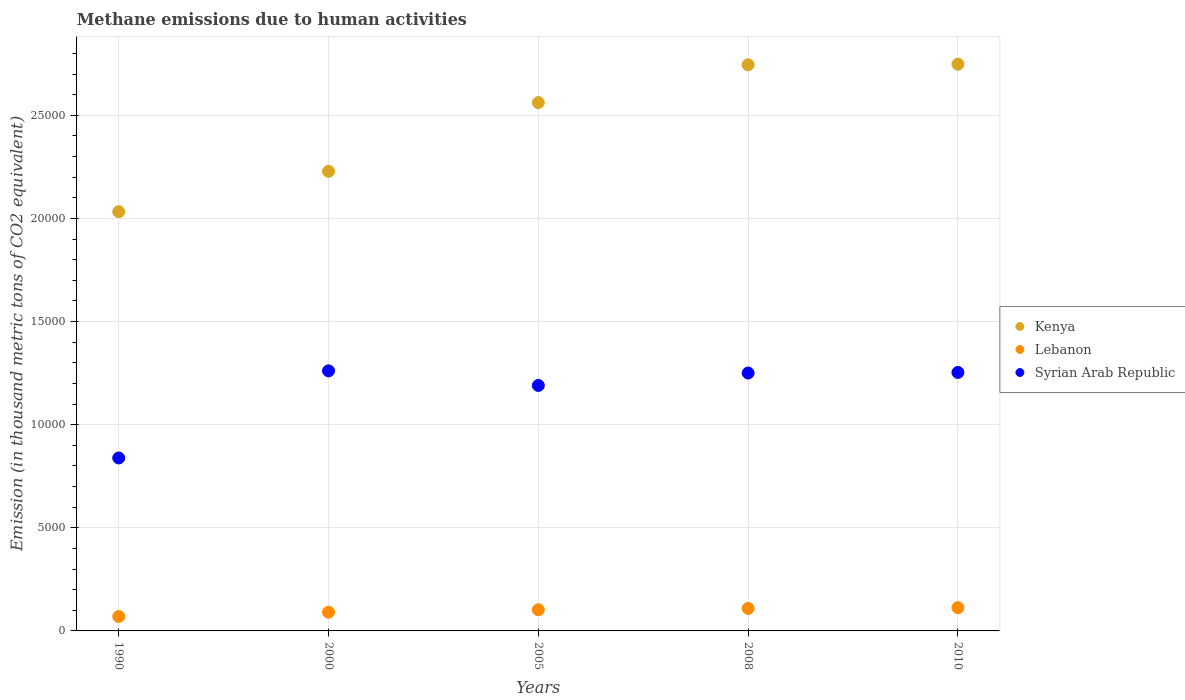How many different coloured dotlines are there?
Give a very brief answer. 3. What is the amount of methane emitted in Syrian Arab Republic in 2000?
Give a very brief answer. 1.26e+04. Across all years, what is the maximum amount of methane emitted in Syrian Arab Republic?
Provide a succinct answer. 1.26e+04. Across all years, what is the minimum amount of methane emitted in Lebanon?
Make the answer very short. 699. In which year was the amount of methane emitted in Lebanon maximum?
Make the answer very short. 2010. What is the total amount of methane emitted in Kenya in the graph?
Provide a short and direct response. 1.23e+05. What is the difference between the amount of methane emitted in Kenya in 1990 and that in 2000?
Offer a terse response. -1959.7. What is the difference between the amount of methane emitted in Lebanon in 1990 and the amount of methane emitted in Syrian Arab Republic in 2010?
Provide a succinct answer. -1.18e+04. What is the average amount of methane emitted in Kenya per year?
Offer a terse response. 2.46e+04. In the year 2010, what is the difference between the amount of methane emitted in Lebanon and amount of methane emitted in Syrian Arab Republic?
Keep it short and to the point. -1.14e+04. In how many years, is the amount of methane emitted in Syrian Arab Republic greater than 9000 thousand metric tons?
Offer a very short reply. 4. What is the ratio of the amount of methane emitted in Kenya in 1990 to that in 2005?
Give a very brief answer. 0.79. Is the difference between the amount of methane emitted in Lebanon in 1990 and 2005 greater than the difference between the amount of methane emitted in Syrian Arab Republic in 1990 and 2005?
Keep it short and to the point. Yes. What is the difference between the highest and the second highest amount of methane emitted in Kenya?
Your answer should be very brief. 29.4. What is the difference between the highest and the lowest amount of methane emitted in Lebanon?
Provide a short and direct response. 428.4. Is the sum of the amount of methane emitted in Syrian Arab Republic in 1990 and 2005 greater than the maximum amount of methane emitted in Lebanon across all years?
Offer a very short reply. Yes. Is it the case that in every year, the sum of the amount of methane emitted in Syrian Arab Republic and amount of methane emitted in Kenya  is greater than the amount of methane emitted in Lebanon?
Give a very brief answer. Yes. Does the amount of methane emitted in Syrian Arab Republic monotonically increase over the years?
Provide a succinct answer. No. Is the amount of methane emitted in Syrian Arab Republic strictly less than the amount of methane emitted in Lebanon over the years?
Offer a terse response. No. Are the values on the major ticks of Y-axis written in scientific E-notation?
Your response must be concise. No. Does the graph contain grids?
Offer a terse response. Yes. Where does the legend appear in the graph?
Provide a succinct answer. Center right. What is the title of the graph?
Make the answer very short. Methane emissions due to human activities. What is the label or title of the X-axis?
Ensure brevity in your answer.  Years. What is the label or title of the Y-axis?
Make the answer very short. Emission (in thousand metric tons of CO2 equivalent). What is the Emission (in thousand metric tons of CO2 equivalent) of Kenya in 1990?
Your answer should be very brief. 2.03e+04. What is the Emission (in thousand metric tons of CO2 equivalent) of Lebanon in 1990?
Offer a very short reply. 699. What is the Emission (in thousand metric tons of CO2 equivalent) of Syrian Arab Republic in 1990?
Your response must be concise. 8384.9. What is the Emission (in thousand metric tons of CO2 equivalent) in Kenya in 2000?
Keep it short and to the point. 2.23e+04. What is the Emission (in thousand metric tons of CO2 equivalent) in Lebanon in 2000?
Your response must be concise. 906.6. What is the Emission (in thousand metric tons of CO2 equivalent) of Syrian Arab Republic in 2000?
Your answer should be compact. 1.26e+04. What is the Emission (in thousand metric tons of CO2 equivalent) of Kenya in 2005?
Give a very brief answer. 2.56e+04. What is the Emission (in thousand metric tons of CO2 equivalent) in Lebanon in 2005?
Give a very brief answer. 1024.8. What is the Emission (in thousand metric tons of CO2 equivalent) in Syrian Arab Republic in 2005?
Your answer should be very brief. 1.19e+04. What is the Emission (in thousand metric tons of CO2 equivalent) in Kenya in 2008?
Ensure brevity in your answer.  2.74e+04. What is the Emission (in thousand metric tons of CO2 equivalent) in Lebanon in 2008?
Your response must be concise. 1091.7. What is the Emission (in thousand metric tons of CO2 equivalent) in Syrian Arab Republic in 2008?
Offer a terse response. 1.25e+04. What is the Emission (in thousand metric tons of CO2 equivalent) of Kenya in 2010?
Make the answer very short. 2.75e+04. What is the Emission (in thousand metric tons of CO2 equivalent) in Lebanon in 2010?
Your answer should be compact. 1127.4. What is the Emission (in thousand metric tons of CO2 equivalent) in Syrian Arab Republic in 2010?
Offer a very short reply. 1.25e+04. Across all years, what is the maximum Emission (in thousand metric tons of CO2 equivalent) in Kenya?
Your answer should be compact. 2.75e+04. Across all years, what is the maximum Emission (in thousand metric tons of CO2 equivalent) of Lebanon?
Offer a very short reply. 1127.4. Across all years, what is the maximum Emission (in thousand metric tons of CO2 equivalent) of Syrian Arab Republic?
Your answer should be very brief. 1.26e+04. Across all years, what is the minimum Emission (in thousand metric tons of CO2 equivalent) of Kenya?
Provide a short and direct response. 2.03e+04. Across all years, what is the minimum Emission (in thousand metric tons of CO2 equivalent) in Lebanon?
Make the answer very short. 699. Across all years, what is the minimum Emission (in thousand metric tons of CO2 equivalent) in Syrian Arab Republic?
Your response must be concise. 8384.9. What is the total Emission (in thousand metric tons of CO2 equivalent) of Kenya in the graph?
Offer a very short reply. 1.23e+05. What is the total Emission (in thousand metric tons of CO2 equivalent) of Lebanon in the graph?
Ensure brevity in your answer.  4849.5. What is the total Emission (in thousand metric tons of CO2 equivalent) in Syrian Arab Republic in the graph?
Your answer should be very brief. 5.79e+04. What is the difference between the Emission (in thousand metric tons of CO2 equivalent) in Kenya in 1990 and that in 2000?
Offer a very short reply. -1959.7. What is the difference between the Emission (in thousand metric tons of CO2 equivalent) in Lebanon in 1990 and that in 2000?
Give a very brief answer. -207.6. What is the difference between the Emission (in thousand metric tons of CO2 equivalent) in Syrian Arab Republic in 1990 and that in 2000?
Ensure brevity in your answer.  -4223.9. What is the difference between the Emission (in thousand metric tons of CO2 equivalent) in Kenya in 1990 and that in 2005?
Give a very brief answer. -5291.2. What is the difference between the Emission (in thousand metric tons of CO2 equivalent) of Lebanon in 1990 and that in 2005?
Make the answer very short. -325.8. What is the difference between the Emission (in thousand metric tons of CO2 equivalent) of Syrian Arab Republic in 1990 and that in 2005?
Ensure brevity in your answer.  -3516.3. What is the difference between the Emission (in thousand metric tons of CO2 equivalent) in Kenya in 1990 and that in 2008?
Keep it short and to the point. -7123.6. What is the difference between the Emission (in thousand metric tons of CO2 equivalent) of Lebanon in 1990 and that in 2008?
Offer a very short reply. -392.7. What is the difference between the Emission (in thousand metric tons of CO2 equivalent) in Syrian Arab Republic in 1990 and that in 2008?
Provide a succinct answer. -4118.9. What is the difference between the Emission (in thousand metric tons of CO2 equivalent) of Kenya in 1990 and that in 2010?
Offer a terse response. -7153. What is the difference between the Emission (in thousand metric tons of CO2 equivalent) in Lebanon in 1990 and that in 2010?
Your answer should be very brief. -428.4. What is the difference between the Emission (in thousand metric tons of CO2 equivalent) in Syrian Arab Republic in 1990 and that in 2010?
Provide a short and direct response. -4147.2. What is the difference between the Emission (in thousand metric tons of CO2 equivalent) in Kenya in 2000 and that in 2005?
Provide a short and direct response. -3331.5. What is the difference between the Emission (in thousand metric tons of CO2 equivalent) in Lebanon in 2000 and that in 2005?
Provide a short and direct response. -118.2. What is the difference between the Emission (in thousand metric tons of CO2 equivalent) of Syrian Arab Republic in 2000 and that in 2005?
Make the answer very short. 707.6. What is the difference between the Emission (in thousand metric tons of CO2 equivalent) of Kenya in 2000 and that in 2008?
Keep it short and to the point. -5163.9. What is the difference between the Emission (in thousand metric tons of CO2 equivalent) in Lebanon in 2000 and that in 2008?
Offer a very short reply. -185.1. What is the difference between the Emission (in thousand metric tons of CO2 equivalent) of Syrian Arab Republic in 2000 and that in 2008?
Give a very brief answer. 105. What is the difference between the Emission (in thousand metric tons of CO2 equivalent) in Kenya in 2000 and that in 2010?
Your response must be concise. -5193.3. What is the difference between the Emission (in thousand metric tons of CO2 equivalent) in Lebanon in 2000 and that in 2010?
Ensure brevity in your answer.  -220.8. What is the difference between the Emission (in thousand metric tons of CO2 equivalent) in Syrian Arab Republic in 2000 and that in 2010?
Your answer should be compact. 76.7. What is the difference between the Emission (in thousand metric tons of CO2 equivalent) in Kenya in 2005 and that in 2008?
Keep it short and to the point. -1832.4. What is the difference between the Emission (in thousand metric tons of CO2 equivalent) of Lebanon in 2005 and that in 2008?
Provide a succinct answer. -66.9. What is the difference between the Emission (in thousand metric tons of CO2 equivalent) of Syrian Arab Republic in 2005 and that in 2008?
Your response must be concise. -602.6. What is the difference between the Emission (in thousand metric tons of CO2 equivalent) in Kenya in 2005 and that in 2010?
Give a very brief answer. -1861.8. What is the difference between the Emission (in thousand metric tons of CO2 equivalent) of Lebanon in 2005 and that in 2010?
Make the answer very short. -102.6. What is the difference between the Emission (in thousand metric tons of CO2 equivalent) of Syrian Arab Republic in 2005 and that in 2010?
Your response must be concise. -630.9. What is the difference between the Emission (in thousand metric tons of CO2 equivalent) in Kenya in 2008 and that in 2010?
Offer a very short reply. -29.4. What is the difference between the Emission (in thousand metric tons of CO2 equivalent) in Lebanon in 2008 and that in 2010?
Ensure brevity in your answer.  -35.7. What is the difference between the Emission (in thousand metric tons of CO2 equivalent) of Syrian Arab Republic in 2008 and that in 2010?
Make the answer very short. -28.3. What is the difference between the Emission (in thousand metric tons of CO2 equivalent) in Kenya in 1990 and the Emission (in thousand metric tons of CO2 equivalent) in Lebanon in 2000?
Provide a succinct answer. 1.94e+04. What is the difference between the Emission (in thousand metric tons of CO2 equivalent) of Kenya in 1990 and the Emission (in thousand metric tons of CO2 equivalent) of Syrian Arab Republic in 2000?
Your response must be concise. 7715.5. What is the difference between the Emission (in thousand metric tons of CO2 equivalent) of Lebanon in 1990 and the Emission (in thousand metric tons of CO2 equivalent) of Syrian Arab Republic in 2000?
Your answer should be compact. -1.19e+04. What is the difference between the Emission (in thousand metric tons of CO2 equivalent) of Kenya in 1990 and the Emission (in thousand metric tons of CO2 equivalent) of Lebanon in 2005?
Provide a succinct answer. 1.93e+04. What is the difference between the Emission (in thousand metric tons of CO2 equivalent) of Kenya in 1990 and the Emission (in thousand metric tons of CO2 equivalent) of Syrian Arab Republic in 2005?
Give a very brief answer. 8423.1. What is the difference between the Emission (in thousand metric tons of CO2 equivalent) in Lebanon in 1990 and the Emission (in thousand metric tons of CO2 equivalent) in Syrian Arab Republic in 2005?
Your answer should be very brief. -1.12e+04. What is the difference between the Emission (in thousand metric tons of CO2 equivalent) in Kenya in 1990 and the Emission (in thousand metric tons of CO2 equivalent) in Lebanon in 2008?
Your answer should be compact. 1.92e+04. What is the difference between the Emission (in thousand metric tons of CO2 equivalent) of Kenya in 1990 and the Emission (in thousand metric tons of CO2 equivalent) of Syrian Arab Republic in 2008?
Make the answer very short. 7820.5. What is the difference between the Emission (in thousand metric tons of CO2 equivalent) in Lebanon in 1990 and the Emission (in thousand metric tons of CO2 equivalent) in Syrian Arab Republic in 2008?
Give a very brief answer. -1.18e+04. What is the difference between the Emission (in thousand metric tons of CO2 equivalent) of Kenya in 1990 and the Emission (in thousand metric tons of CO2 equivalent) of Lebanon in 2010?
Provide a succinct answer. 1.92e+04. What is the difference between the Emission (in thousand metric tons of CO2 equivalent) of Kenya in 1990 and the Emission (in thousand metric tons of CO2 equivalent) of Syrian Arab Republic in 2010?
Your response must be concise. 7792.2. What is the difference between the Emission (in thousand metric tons of CO2 equivalent) in Lebanon in 1990 and the Emission (in thousand metric tons of CO2 equivalent) in Syrian Arab Republic in 2010?
Keep it short and to the point. -1.18e+04. What is the difference between the Emission (in thousand metric tons of CO2 equivalent) of Kenya in 2000 and the Emission (in thousand metric tons of CO2 equivalent) of Lebanon in 2005?
Your response must be concise. 2.13e+04. What is the difference between the Emission (in thousand metric tons of CO2 equivalent) in Kenya in 2000 and the Emission (in thousand metric tons of CO2 equivalent) in Syrian Arab Republic in 2005?
Provide a short and direct response. 1.04e+04. What is the difference between the Emission (in thousand metric tons of CO2 equivalent) of Lebanon in 2000 and the Emission (in thousand metric tons of CO2 equivalent) of Syrian Arab Republic in 2005?
Ensure brevity in your answer.  -1.10e+04. What is the difference between the Emission (in thousand metric tons of CO2 equivalent) in Kenya in 2000 and the Emission (in thousand metric tons of CO2 equivalent) in Lebanon in 2008?
Give a very brief answer. 2.12e+04. What is the difference between the Emission (in thousand metric tons of CO2 equivalent) in Kenya in 2000 and the Emission (in thousand metric tons of CO2 equivalent) in Syrian Arab Republic in 2008?
Your response must be concise. 9780.2. What is the difference between the Emission (in thousand metric tons of CO2 equivalent) in Lebanon in 2000 and the Emission (in thousand metric tons of CO2 equivalent) in Syrian Arab Republic in 2008?
Your response must be concise. -1.16e+04. What is the difference between the Emission (in thousand metric tons of CO2 equivalent) of Kenya in 2000 and the Emission (in thousand metric tons of CO2 equivalent) of Lebanon in 2010?
Provide a succinct answer. 2.12e+04. What is the difference between the Emission (in thousand metric tons of CO2 equivalent) in Kenya in 2000 and the Emission (in thousand metric tons of CO2 equivalent) in Syrian Arab Republic in 2010?
Your answer should be compact. 9751.9. What is the difference between the Emission (in thousand metric tons of CO2 equivalent) in Lebanon in 2000 and the Emission (in thousand metric tons of CO2 equivalent) in Syrian Arab Republic in 2010?
Give a very brief answer. -1.16e+04. What is the difference between the Emission (in thousand metric tons of CO2 equivalent) in Kenya in 2005 and the Emission (in thousand metric tons of CO2 equivalent) in Lebanon in 2008?
Keep it short and to the point. 2.45e+04. What is the difference between the Emission (in thousand metric tons of CO2 equivalent) in Kenya in 2005 and the Emission (in thousand metric tons of CO2 equivalent) in Syrian Arab Republic in 2008?
Give a very brief answer. 1.31e+04. What is the difference between the Emission (in thousand metric tons of CO2 equivalent) in Lebanon in 2005 and the Emission (in thousand metric tons of CO2 equivalent) in Syrian Arab Republic in 2008?
Offer a very short reply. -1.15e+04. What is the difference between the Emission (in thousand metric tons of CO2 equivalent) in Kenya in 2005 and the Emission (in thousand metric tons of CO2 equivalent) in Lebanon in 2010?
Keep it short and to the point. 2.45e+04. What is the difference between the Emission (in thousand metric tons of CO2 equivalent) of Kenya in 2005 and the Emission (in thousand metric tons of CO2 equivalent) of Syrian Arab Republic in 2010?
Keep it short and to the point. 1.31e+04. What is the difference between the Emission (in thousand metric tons of CO2 equivalent) in Lebanon in 2005 and the Emission (in thousand metric tons of CO2 equivalent) in Syrian Arab Republic in 2010?
Give a very brief answer. -1.15e+04. What is the difference between the Emission (in thousand metric tons of CO2 equivalent) in Kenya in 2008 and the Emission (in thousand metric tons of CO2 equivalent) in Lebanon in 2010?
Make the answer very short. 2.63e+04. What is the difference between the Emission (in thousand metric tons of CO2 equivalent) in Kenya in 2008 and the Emission (in thousand metric tons of CO2 equivalent) in Syrian Arab Republic in 2010?
Your response must be concise. 1.49e+04. What is the difference between the Emission (in thousand metric tons of CO2 equivalent) of Lebanon in 2008 and the Emission (in thousand metric tons of CO2 equivalent) of Syrian Arab Republic in 2010?
Make the answer very short. -1.14e+04. What is the average Emission (in thousand metric tons of CO2 equivalent) of Kenya per year?
Offer a very short reply. 2.46e+04. What is the average Emission (in thousand metric tons of CO2 equivalent) in Lebanon per year?
Your answer should be very brief. 969.9. What is the average Emission (in thousand metric tons of CO2 equivalent) in Syrian Arab Republic per year?
Your answer should be very brief. 1.16e+04. In the year 1990, what is the difference between the Emission (in thousand metric tons of CO2 equivalent) of Kenya and Emission (in thousand metric tons of CO2 equivalent) of Lebanon?
Give a very brief answer. 1.96e+04. In the year 1990, what is the difference between the Emission (in thousand metric tons of CO2 equivalent) in Kenya and Emission (in thousand metric tons of CO2 equivalent) in Syrian Arab Republic?
Keep it short and to the point. 1.19e+04. In the year 1990, what is the difference between the Emission (in thousand metric tons of CO2 equivalent) in Lebanon and Emission (in thousand metric tons of CO2 equivalent) in Syrian Arab Republic?
Your answer should be very brief. -7685.9. In the year 2000, what is the difference between the Emission (in thousand metric tons of CO2 equivalent) of Kenya and Emission (in thousand metric tons of CO2 equivalent) of Lebanon?
Keep it short and to the point. 2.14e+04. In the year 2000, what is the difference between the Emission (in thousand metric tons of CO2 equivalent) of Kenya and Emission (in thousand metric tons of CO2 equivalent) of Syrian Arab Republic?
Give a very brief answer. 9675.2. In the year 2000, what is the difference between the Emission (in thousand metric tons of CO2 equivalent) in Lebanon and Emission (in thousand metric tons of CO2 equivalent) in Syrian Arab Republic?
Offer a very short reply. -1.17e+04. In the year 2005, what is the difference between the Emission (in thousand metric tons of CO2 equivalent) of Kenya and Emission (in thousand metric tons of CO2 equivalent) of Lebanon?
Your response must be concise. 2.46e+04. In the year 2005, what is the difference between the Emission (in thousand metric tons of CO2 equivalent) in Kenya and Emission (in thousand metric tons of CO2 equivalent) in Syrian Arab Republic?
Offer a terse response. 1.37e+04. In the year 2005, what is the difference between the Emission (in thousand metric tons of CO2 equivalent) of Lebanon and Emission (in thousand metric tons of CO2 equivalent) of Syrian Arab Republic?
Your answer should be very brief. -1.09e+04. In the year 2008, what is the difference between the Emission (in thousand metric tons of CO2 equivalent) in Kenya and Emission (in thousand metric tons of CO2 equivalent) in Lebanon?
Keep it short and to the point. 2.64e+04. In the year 2008, what is the difference between the Emission (in thousand metric tons of CO2 equivalent) of Kenya and Emission (in thousand metric tons of CO2 equivalent) of Syrian Arab Republic?
Provide a short and direct response. 1.49e+04. In the year 2008, what is the difference between the Emission (in thousand metric tons of CO2 equivalent) in Lebanon and Emission (in thousand metric tons of CO2 equivalent) in Syrian Arab Republic?
Ensure brevity in your answer.  -1.14e+04. In the year 2010, what is the difference between the Emission (in thousand metric tons of CO2 equivalent) of Kenya and Emission (in thousand metric tons of CO2 equivalent) of Lebanon?
Provide a succinct answer. 2.63e+04. In the year 2010, what is the difference between the Emission (in thousand metric tons of CO2 equivalent) of Kenya and Emission (in thousand metric tons of CO2 equivalent) of Syrian Arab Republic?
Provide a short and direct response. 1.49e+04. In the year 2010, what is the difference between the Emission (in thousand metric tons of CO2 equivalent) in Lebanon and Emission (in thousand metric tons of CO2 equivalent) in Syrian Arab Republic?
Provide a short and direct response. -1.14e+04. What is the ratio of the Emission (in thousand metric tons of CO2 equivalent) of Kenya in 1990 to that in 2000?
Make the answer very short. 0.91. What is the ratio of the Emission (in thousand metric tons of CO2 equivalent) of Lebanon in 1990 to that in 2000?
Keep it short and to the point. 0.77. What is the ratio of the Emission (in thousand metric tons of CO2 equivalent) in Syrian Arab Republic in 1990 to that in 2000?
Your answer should be compact. 0.67. What is the ratio of the Emission (in thousand metric tons of CO2 equivalent) of Kenya in 1990 to that in 2005?
Ensure brevity in your answer.  0.79. What is the ratio of the Emission (in thousand metric tons of CO2 equivalent) of Lebanon in 1990 to that in 2005?
Your response must be concise. 0.68. What is the ratio of the Emission (in thousand metric tons of CO2 equivalent) of Syrian Arab Republic in 1990 to that in 2005?
Your answer should be compact. 0.7. What is the ratio of the Emission (in thousand metric tons of CO2 equivalent) in Kenya in 1990 to that in 2008?
Offer a very short reply. 0.74. What is the ratio of the Emission (in thousand metric tons of CO2 equivalent) of Lebanon in 1990 to that in 2008?
Your response must be concise. 0.64. What is the ratio of the Emission (in thousand metric tons of CO2 equivalent) in Syrian Arab Republic in 1990 to that in 2008?
Your answer should be compact. 0.67. What is the ratio of the Emission (in thousand metric tons of CO2 equivalent) of Kenya in 1990 to that in 2010?
Offer a very short reply. 0.74. What is the ratio of the Emission (in thousand metric tons of CO2 equivalent) of Lebanon in 1990 to that in 2010?
Provide a short and direct response. 0.62. What is the ratio of the Emission (in thousand metric tons of CO2 equivalent) of Syrian Arab Republic in 1990 to that in 2010?
Provide a short and direct response. 0.67. What is the ratio of the Emission (in thousand metric tons of CO2 equivalent) in Kenya in 2000 to that in 2005?
Offer a very short reply. 0.87. What is the ratio of the Emission (in thousand metric tons of CO2 equivalent) of Lebanon in 2000 to that in 2005?
Your answer should be compact. 0.88. What is the ratio of the Emission (in thousand metric tons of CO2 equivalent) of Syrian Arab Republic in 2000 to that in 2005?
Your answer should be compact. 1.06. What is the ratio of the Emission (in thousand metric tons of CO2 equivalent) of Kenya in 2000 to that in 2008?
Provide a short and direct response. 0.81. What is the ratio of the Emission (in thousand metric tons of CO2 equivalent) in Lebanon in 2000 to that in 2008?
Your response must be concise. 0.83. What is the ratio of the Emission (in thousand metric tons of CO2 equivalent) in Syrian Arab Republic in 2000 to that in 2008?
Your response must be concise. 1.01. What is the ratio of the Emission (in thousand metric tons of CO2 equivalent) of Kenya in 2000 to that in 2010?
Offer a terse response. 0.81. What is the ratio of the Emission (in thousand metric tons of CO2 equivalent) of Lebanon in 2000 to that in 2010?
Your response must be concise. 0.8. What is the ratio of the Emission (in thousand metric tons of CO2 equivalent) in Syrian Arab Republic in 2000 to that in 2010?
Make the answer very short. 1.01. What is the ratio of the Emission (in thousand metric tons of CO2 equivalent) in Kenya in 2005 to that in 2008?
Offer a very short reply. 0.93. What is the ratio of the Emission (in thousand metric tons of CO2 equivalent) in Lebanon in 2005 to that in 2008?
Your response must be concise. 0.94. What is the ratio of the Emission (in thousand metric tons of CO2 equivalent) in Syrian Arab Republic in 2005 to that in 2008?
Your response must be concise. 0.95. What is the ratio of the Emission (in thousand metric tons of CO2 equivalent) of Kenya in 2005 to that in 2010?
Keep it short and to the point. 0.93. What is the ratio of the Emission (in thousand metric tons of CO2 equivalent) in Lebanon in 2005 to that in 2010?
Provide a succinct answer. 0.91. What is the ratio of the Emission (in thousand metric tons of CO2 equivalent) of Syrian Arab Republic in 2005 to that in 2010?
Your response must be concise. 0.95. What is the ratio of the Emission (in thousand metric tons of CO2 equivalent) in Kenya in 2008 to that in 2010?
Make the answer very short. 1. What is the ratio of the Emission (in thousand metric tons of CO2 equivalent) of Lebanon in 2008 to that in 2010?
Your answer should be compact. 0.97. What is the ratio of the Emission (in thousand metric tons of CO2 equivalent) of Syrian Arab Republic in 2008 to that in 2010?
Give a very brief answer. 1. What is the difference between the highest and the second highest Emission (in thousand metric tons of CO2 equivalent) of Kenya?
Your response must be concise. 29.4. What is the difference between the highest and the second highest Emission (in thousand metric tons of CO2 equivalent) in Lebanon?
Your answer should be very brief. 35.7. What is the difference between the highest and the second highest Emission (in thousand metric tons of CO2 equivalent) in Syrian Arab Republic?
Offer a very short reply. 76.7. What is the difference between the highest and the lowest Emission (in thousand metric tons of CO2 equivalent) in Kenya?
Ensure brevity in your answer.  7153. What is the difference between the highest and the lowest Emission (in thousand metric tons of CO2 equivalent) of Lebanon?
Your answer should be compact. 428.4. What is the difference between the highest and the lowest Emission (in thousand metric tons of CO2 equivalent) in Syrian Arab Republic?
Offer a terse response. 4223.9. 